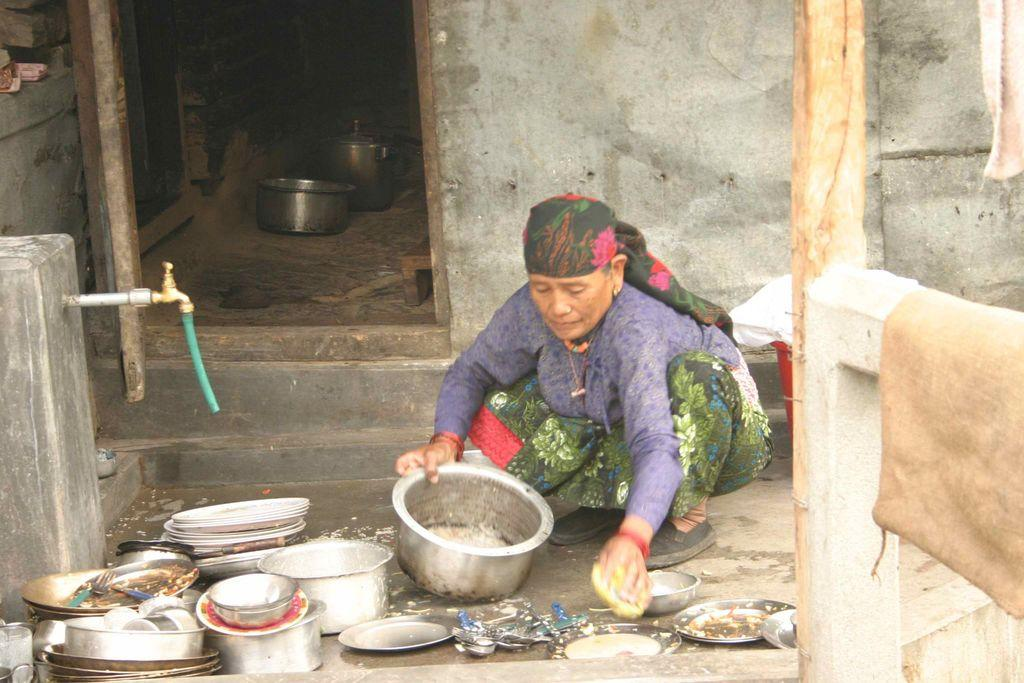Who is the person in the image? There is a woman in the image. What is the woman doing in the image? The woman is washing utensils. What is the source of water in the image? There is a tap in the image. What can be seen behind the woman in the image? There is a wall in the image. What is the means of entering or exiting the room in the image? There is a door in the image. What type of support can be seen in the image? There is no specific support structure visible in the image. Can you recite a verse that is written on the wall in the image? There is no verse written on the wall in the image. 